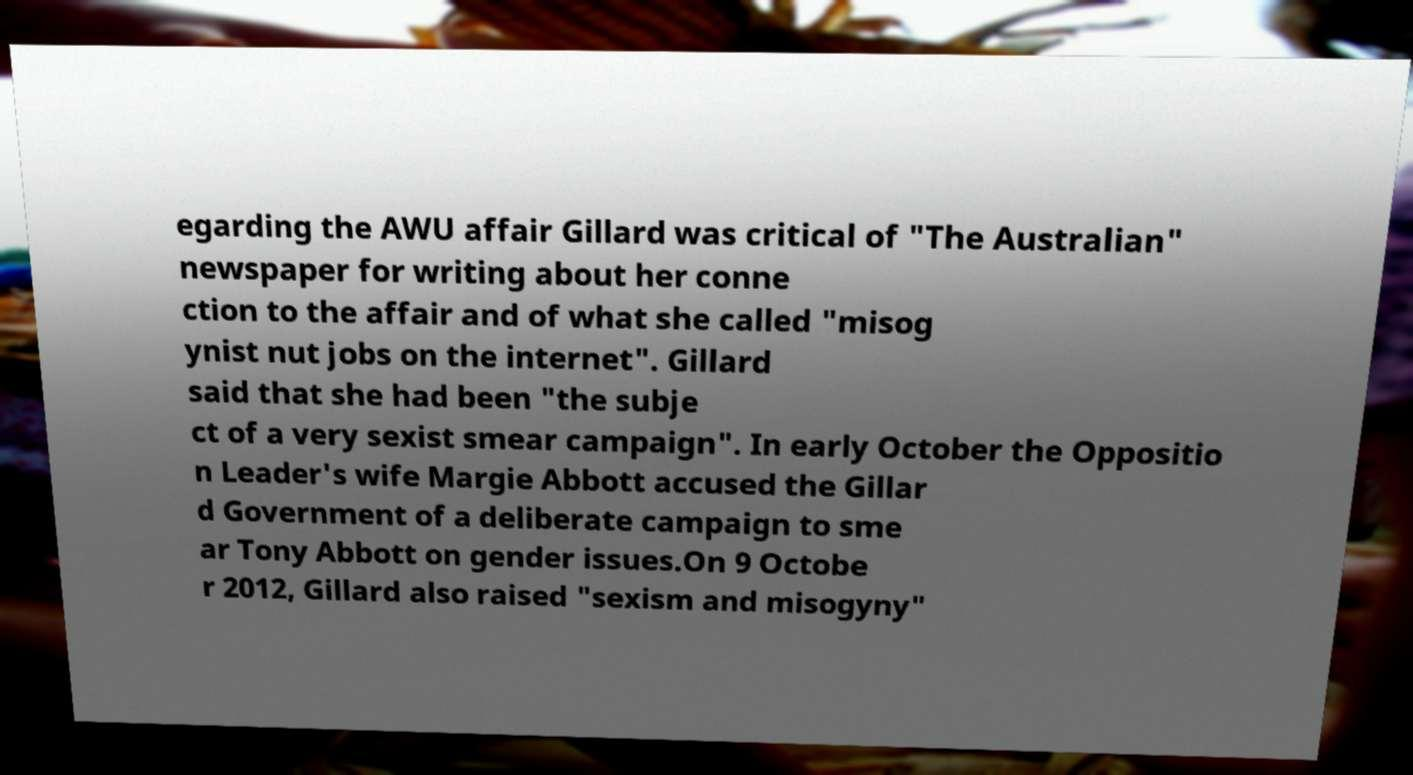I need the written content from this picture converted into text. Can you do that? egarding the AWU affair Gillard was critical of "The Australian" newspaper for writing about her conne ction to the affair and of what she called "misog ynist nut jobs on the internet". Gillard said that she had been "the subje ct of a very sexist smear campaign". In early October the Oppositio n Leader's wife Margie Abbott accused the Gillar d Government of a deliberate campaign to sme ar Tony Abbott on gender issues.On 9 Octobe r 2012, Gillard also raised "sexism and misogyny" 